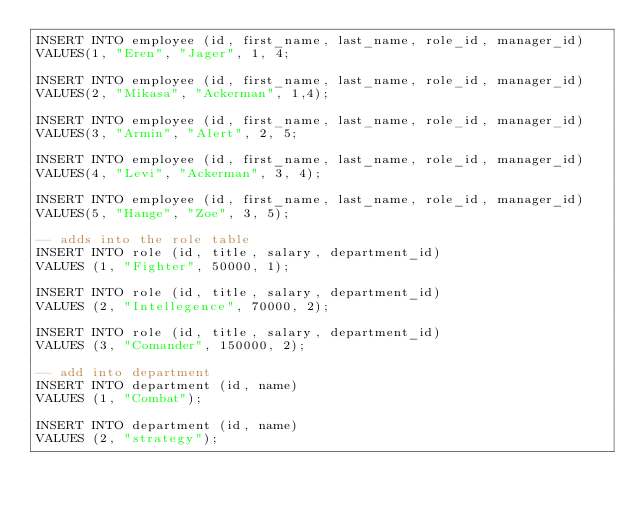<code> <loc_0><loc_0><loc_500><loc_500><_SQL_>INSERT INTO employee (id, first_name, last_name, role_id, manager_id)
VALUES(1, "Eren", "Jager", 1, 4;

INSERT INTO employee (id, first_name, last_name, role_id, manager_id)
VALUES(2, "Mikasa", "Ackerman", 1,4);

INSERT INTO employee (id, first_name, last_name, role_id, manager_id)
VALUES(3, "Armin", "Alert", 2, 5;

INSERT INTO employee (id, first_name, last_name, role_id, manager_id)
VALUES(4, "Levi", "Ackerman", 3, 4);

INSERT INTO employee (id, first_name, last_name, role_id, manager_id)
VALUES(5, "Hange", "Zoe", 3, 5);

-- adds into the role table
INSERT INTO role (id, title, salary, department_id)
VALUES (1, "Fighter", 50000, 1);

INSERT INTO role (id, title, salary, department_id)
VALUES (2, "Intellegence", 70000, 2);

INSERT INTO role (id, title, salary, department_id)
VALUES (3, "Comander", 150000, 2);

-- add into department 
INSERT INTO department (id, name)
VALUES (1, "Combat");

INSERT INTO department (id, name)
VALUES (2, "strategy");

</code> 